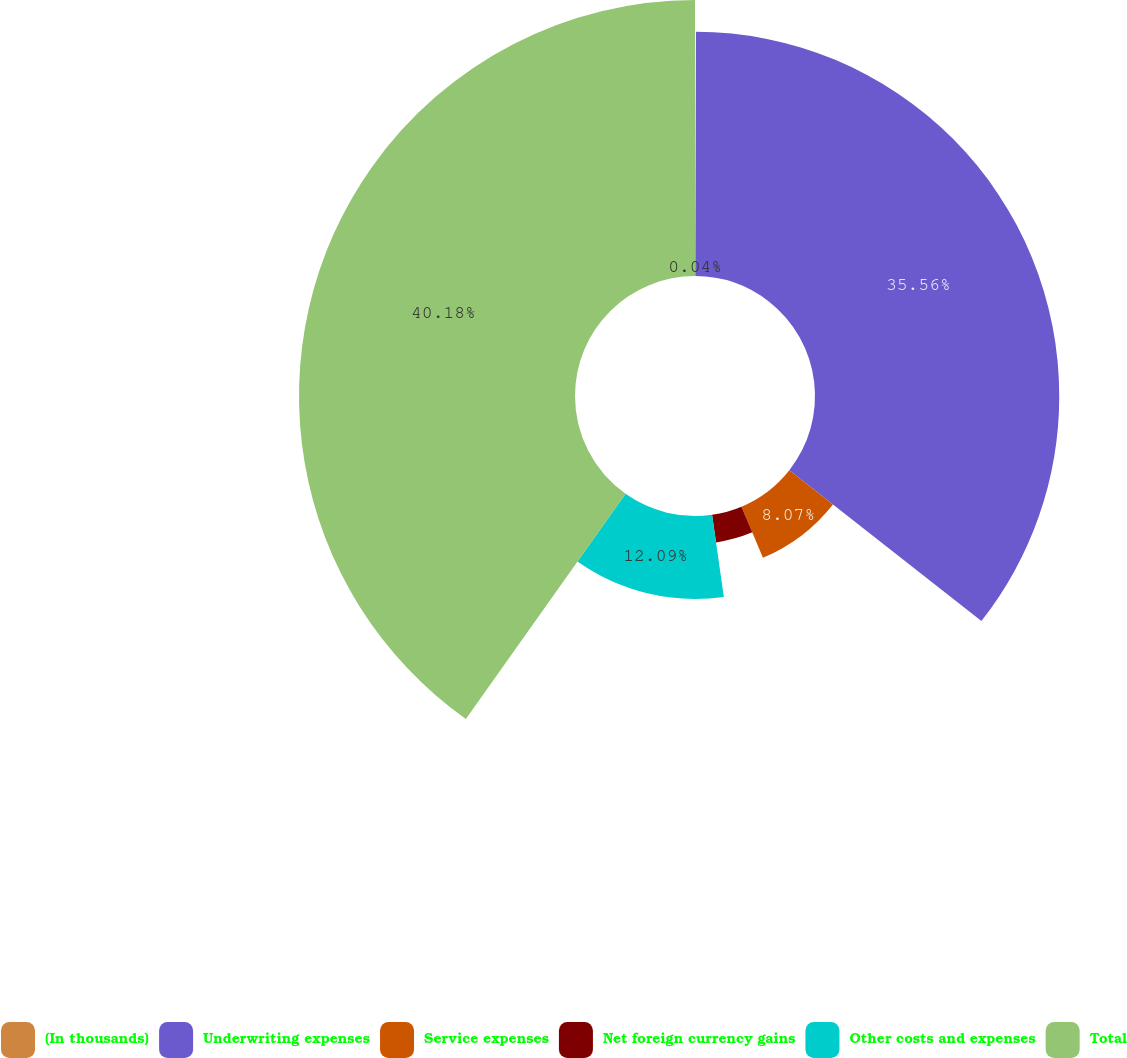Convert chart. <chart><loc_0><loc_0><loc_500><loc_500><pie_chart><fcel>(In thousands)<fcel>Underwriting expenses<fcel>Service expenses<fcel>Net foreign currency gains<fcel>Other costs and expenses<fcel>Total<nl><fcel>0.04%<fcel>35.56%<fcel>8.07%<fcel>4.06%<fcel>12.09%<fcel>40.18%<nl></chart> 